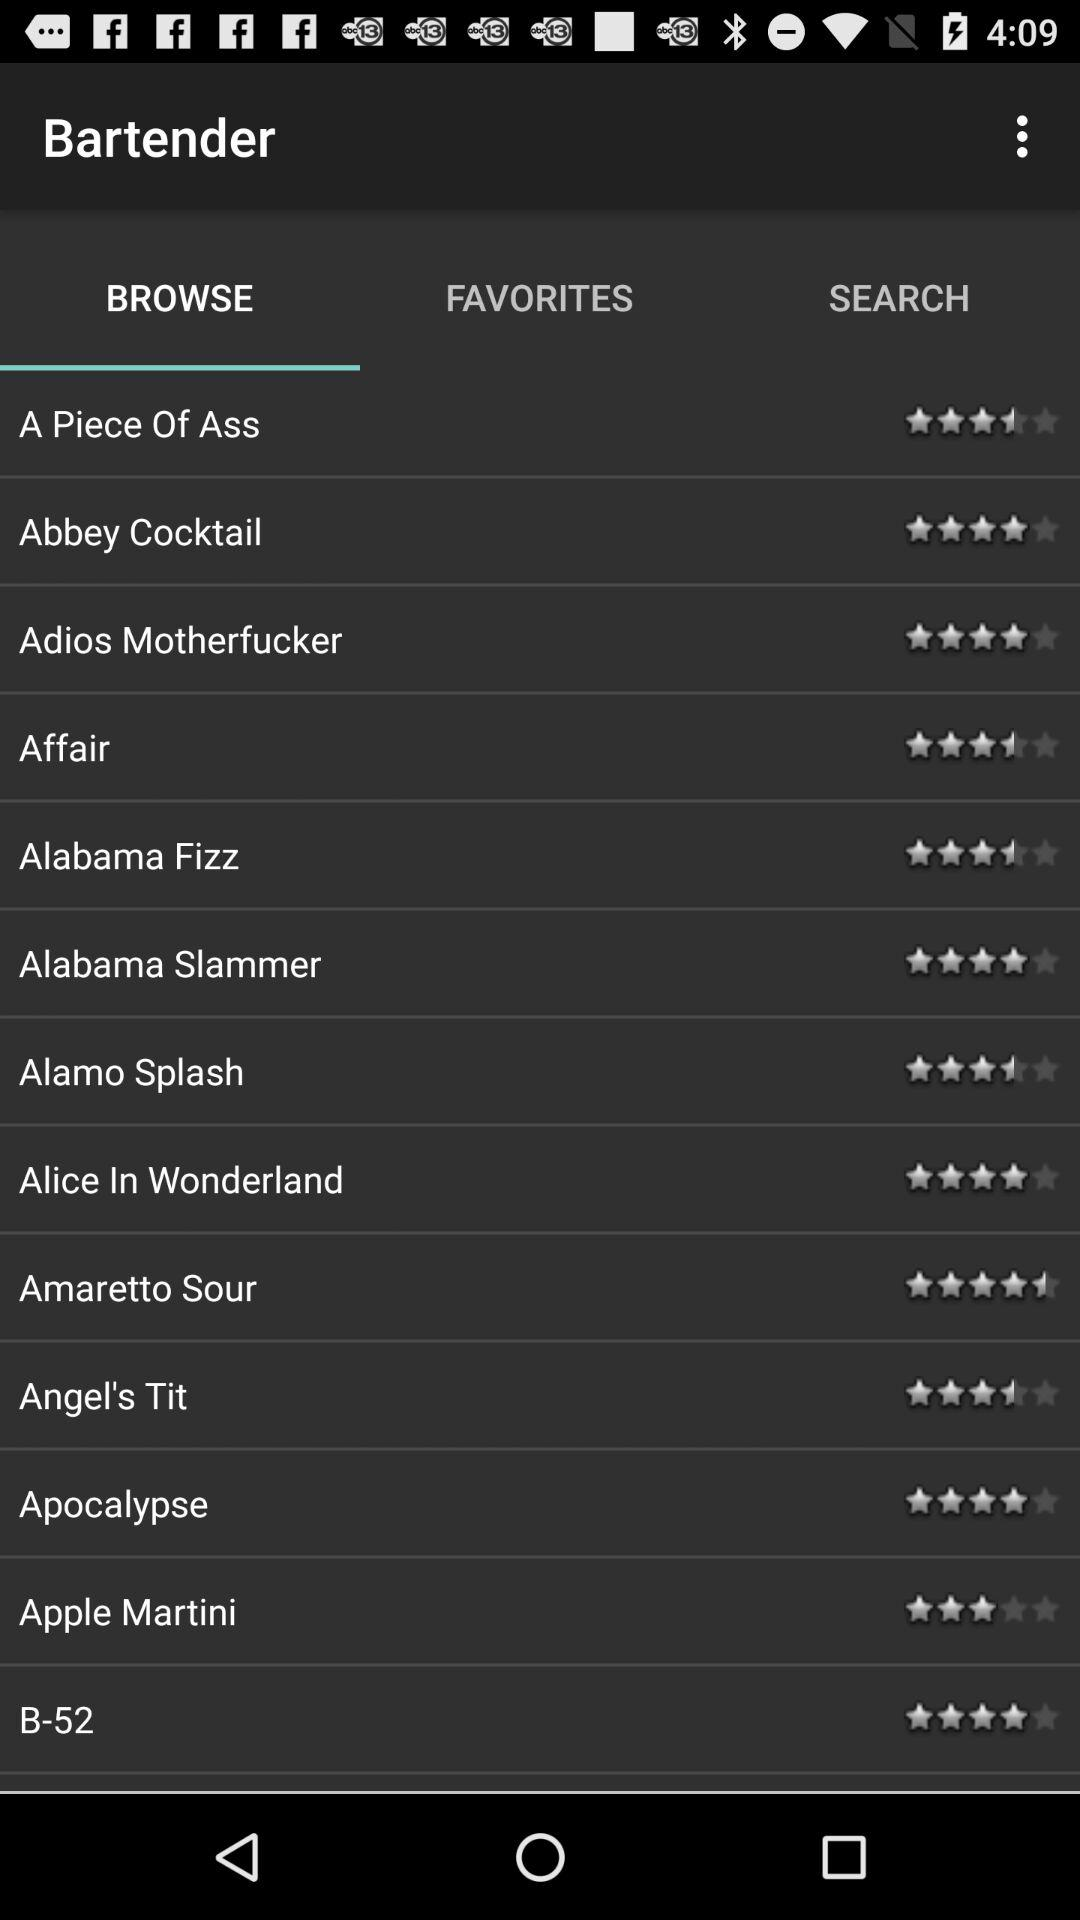Which tab is selected? The selected tab is "BROWSE". 